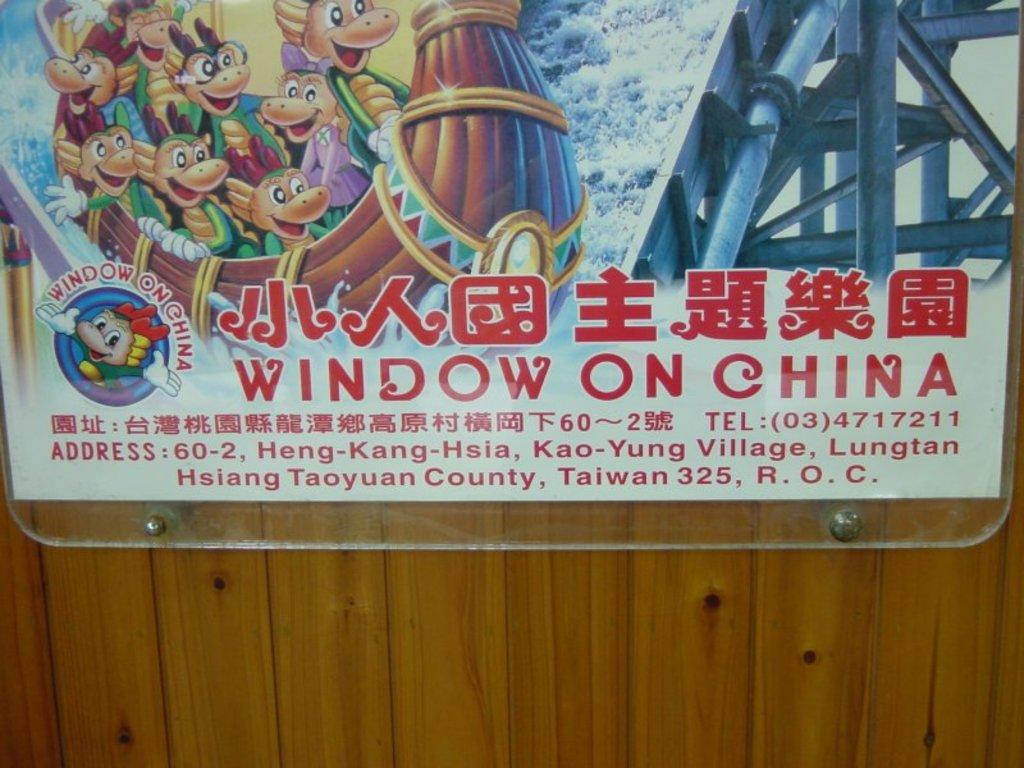What is the name of this theme park?
Your answer should be very brief. Window on china. 